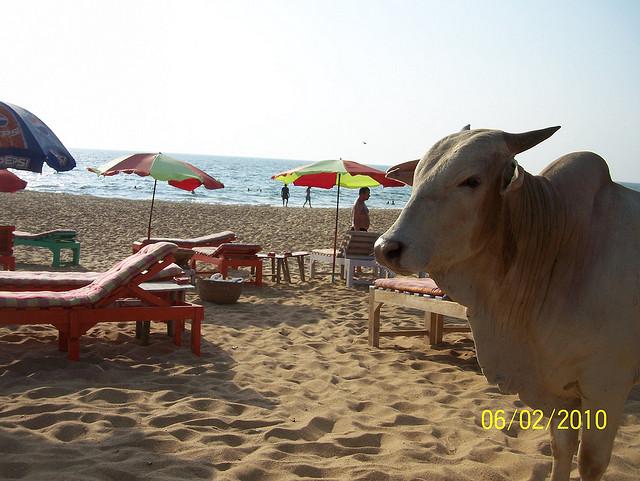Where is this?
Quick response, please. Beach. Is the animal where it belongs?
Keep it brief. No. What is the date in the lower right corner of this photograph?
Short answer required. 06/02/2010. 